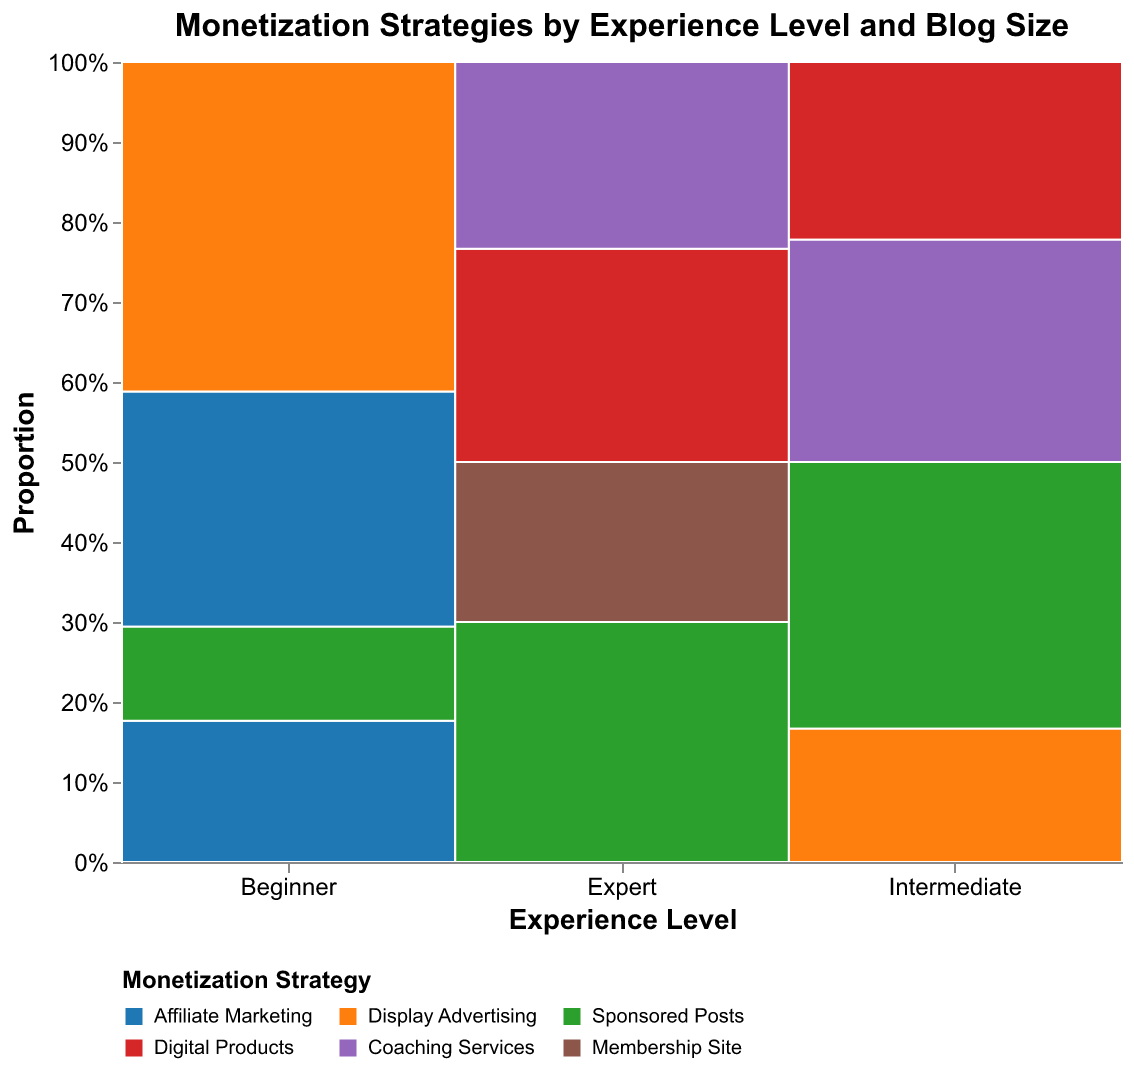Which experience level has the greatest variety of monetization strategies? Look for the experience level with the most distinct colored segments, indicating different monetization strategies. The "Expert" level has the most diversity in monetization strategies.
Answer: Expert Which monetization strategy is most commonly used by beginner bloggers with small blogs? Identify the color blocks corresponding to monetization strategies within the "Beginner" column and "Small (< 10k monthly visitors)" row. The strategy with the largest block area is the most common. The largest block for beginners with small blogs is "Display Advertising."
Answer: Display Advertising How does the proportion of "Sponsored Posts" change with blog size for intermediate bloggers? Look within the "Intermediate" column and compare the yellow color blocks (representing "Sponsored Posts") across different blog sizes. The proportion of "Sponsored Posts" increases from small to medium but is absent in large blogs.
Answer: Increases then absent What is the most common monetization strategy for experts with large blogs? Identify the largest color block under "Expert" with "Large (> 100k monthly visitors)" as the blog size. The largest block is green, representing "Sponsored Posts."
Answer: Sponsored Posts Which monetization strategy is equally used by intermediate bloggers and expert bloggers for medium blog size? Compare the color blocks for "Intermediate" and "Expert" for the "Medium (10k-100k monthly visitors)" blog size. Both groups have significant purple blocks representing "Coaching Services."
Answer: Coaching Services Do expert bloggers with medium-sized blogs use digital products more than coaching services? Compare the block sizes for "Digital Products" (red) and "Coaching Services" (purple) in the "Expert" column under the "Medium (10k-100k monthly visitors)" row. The red block (Digital Products) is larger than the purple block (Coaching Services).
Answer: Yes What is the total count of "Affiliate Marketing" across all blog sizes for beginners? Add the counts of "Affiliate Marketing" strategy (blue color) within the "Beginner" experience level. The counts are 25 for small and 15 for medium, making the total 25 + 15 = 40.
Answer: 40 How does the proportion of "Display Advertising" change with blog size for beginner bloggers? Compare the blue color blocks representing "Display Advertising" within the "Beginner" column across small and medium blog sizes. "Display Advertising" is present only in the small blog size, not medium.
Answer: Only in small blogs What is the difference in the proportion of "Sponsored Posts" between intermediate and expert bloggers with medium blogs? Calculate the relative proportions by comparing the size of yellow blocks in "Intermediate" and "Expert" columns for medium-sized blogs. Intermediate bloggers have one yellow block, while expert bloggers do not. The difference is calculated by figuring out the absence in the expert bloggers.
Answer: Present in Intermediate, none in Expert Which monetization strategy is used the least among all experience levels and blog sizes? Identify the smallest color block in the entire figure across all experience levels and blog sizes. The smallest block, representing the least used strategy, is "Membership Site" for experts with large blogs.
Answer: Membership Site 